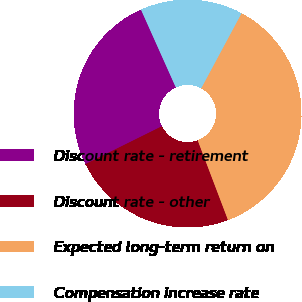<chart> <loc_0><loc_0><loc_500><loc_500><pie_chart><fcel>Discount rate - retirement<fcel>Discount rate - other<fcel>Expected long-term return on<fcel>Compensation increase rate<nl><fcel>25.62%<fcel>23.46%<fcel>36.37%<fcel>14.55%<nl></chart> 